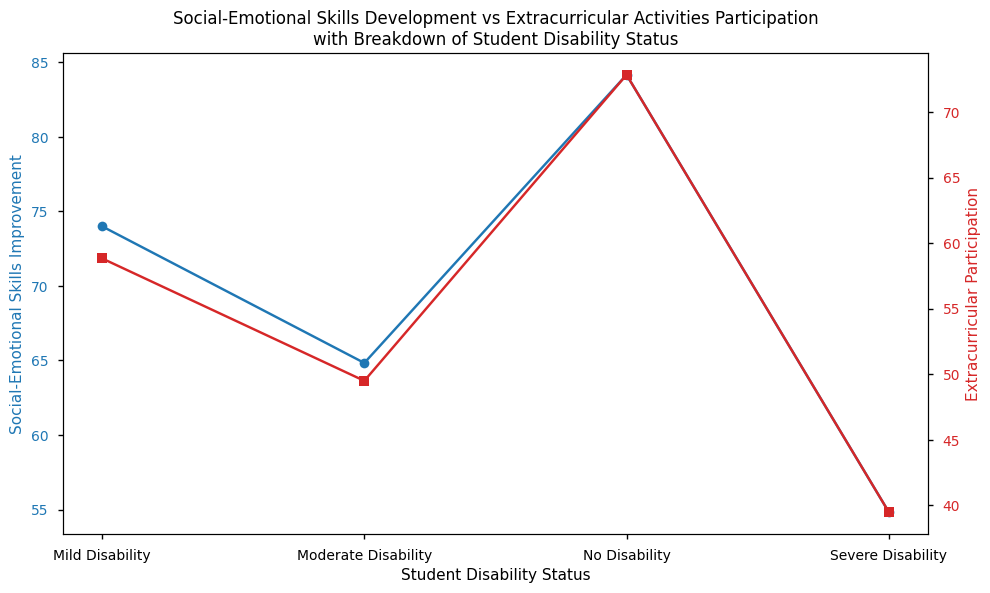What is the average Social-Emotional Skill Improvement for students with mild disabilities? The figure shows the Social-Emotional Skill Improvement for students with mild disabilities at different points. Adding these values together and dividing by the number of points gives the average: (75 + 70 + 78 + 73 + 76 + 72) / 6 = 444 / 6 = 74
Answer: 74 Which group has the highest Extracurricular Participation rate? The figure has a secondary axis depicting Extracurricular Participation. The "No Disability" group shows the highest rate among all the groups.
Answer: No Disability What is the difference in Social-Emotional Skill Improvement between students with No Disability and Severe Disability? From the figure, the Social-Emotional Skill Improvement for "No Disability" is around 85 and for "Severe Disability" is around 55. The difference is 85 - 55 = 30
Answer: 30 By how much does the Extracurricular Participation rate for students with moderate disabilities exceed that of students with severe disabilities? According to the secondary axis, the Extracurricular Participation for moderate disabilities is about 50 and for severe disabilities is around 40. The difference is 50 - 40 = 10
Answer: 10 Is the Social-Emotional Skill Improvement higher for students with mild disabilities compared to students with moderate disabilities? Comparing the points for mild and moderate disabilities on the primary axis, the values for mild disabilities are consistently higher.
Answer: Yes What is the average Extracurricular Participation rate for students with no disability? The values for Extracurricular Participation for students with no disability are 75, 70, 80, 65, 78, and 69. Summing these and dividing by the number of values: (75 + 70 + 80 + 65 + 78 + 69) / 6 = 437 / 6 ≈ 72.83
Answer: 72.83 How does the Social-Emotional Skill Improvement trend as the severity of disability increases? The figure shows a decline in Social-Emotional Skill Improvement as the severity of disability increases from no disability to severe disability.
Answer: Decreases What is the ratio of Social-Emotional Skill Improvement to Extracurricular Participation for students with severe disabilities? The values for students with severe disabilities are about 55 for Social-Emotional Skill Improvement and 40 for Extracurricular Participation. The ratio is 55/40 = 1.375
Answer: 1.375 Do students with moderate disabilities participate more in extracurricular activities than those with mild disabilities? The secondary axis values suggest that students with moderate disabilities have a slightly lower rate of participation compared to students with mild disabilities.
Answer: No 